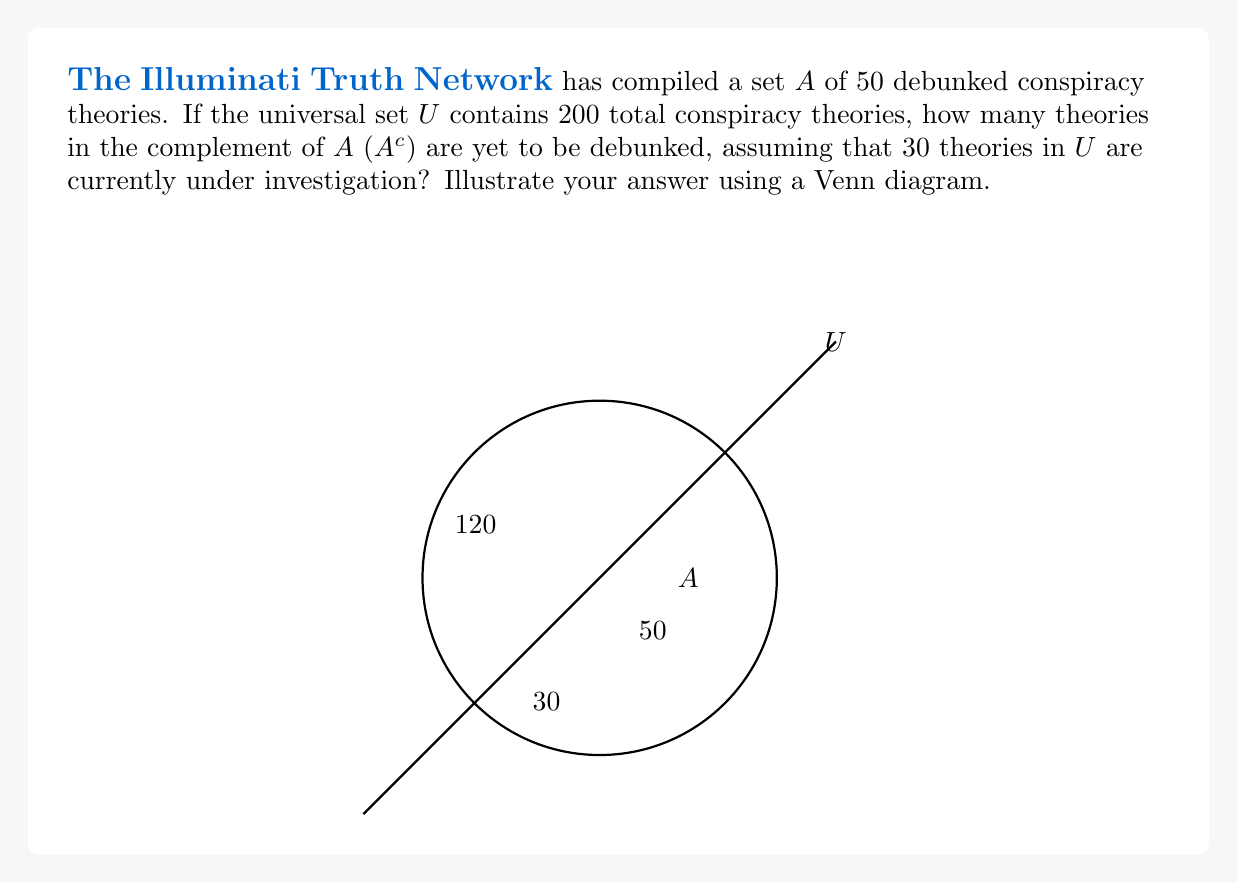Show me your answer to this math problem. Let's approach this step-by-step:

1) First, we need to understand what the complement of set $A$ ($A^c$) represents:
   $A^c$ = All elements in $U$ that are not in $A$

2) We're given:
   - $|U| = 200$ (total theories in the universal set)
   - $|A| = 50$ (debunked theories)
   - 30 theories are under investigation

3) To find $|A^c|$, we use the formula:
   $|A^c| = |U| - |A|$
   $|A^c| = 200 - 50 = 150$

4) Now, we need to subtract the theories under investigation from $|A^c|$:
   Theories in $A^c$ not under investigation = $150 - 30 = 120$

5) Therefore, 120 theories in $A^c$ are yet to be debunked.

The Venn diagram illustrates this:
- The large circle represents $U$ (200 theories)
- The smaller circle represents $A$ (50 debunked theories)
- The area outside $A$ but inside $U$ represents $A^c$ (150 theories)
- Within $A^c$, we have 30 theories under investigation and 120 yet to be debunked
Answer: 120 